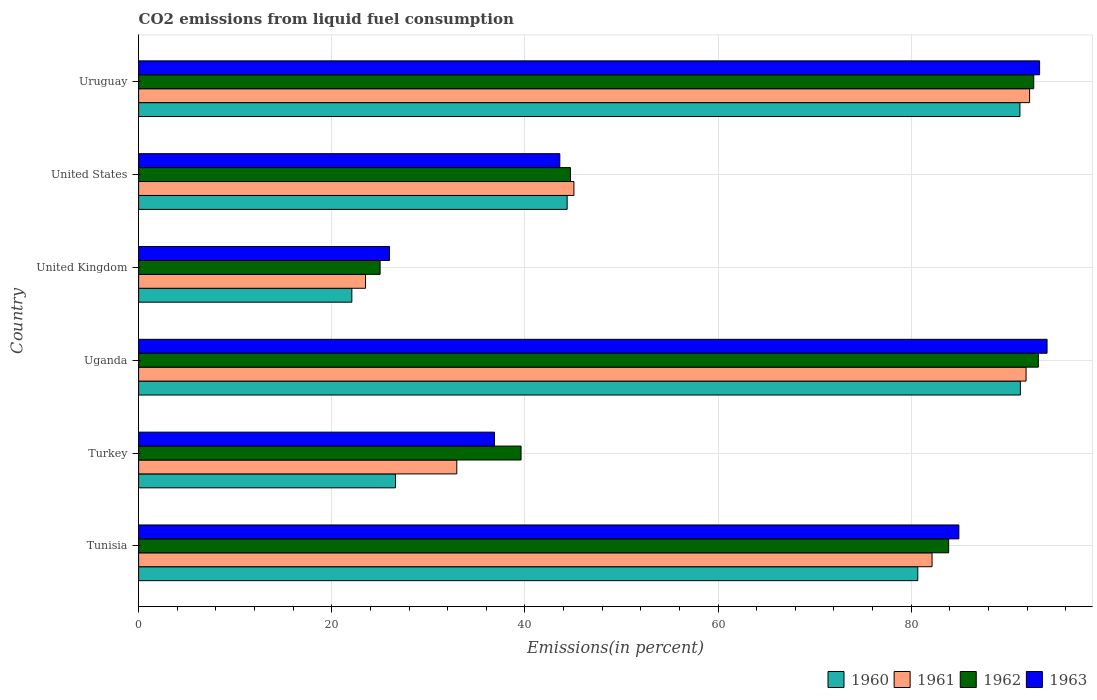How many different coloured bars are there?
Offer a terse response. 4. How many groups of bars are there?
Your response must be concise. 6. Are the number of bars on each tick of the Y-axis equal?
Offer a very short reply. Yes. How many bars are there on the 5th tick from the top?
Your answer should be compact. 4. How many bars are there on the 5th tick from the bottom?
Keep it short and to the point. 4. What is the label of the 1st group of bars from the top?
Your answer should be very brief. Uruguay. What is the total CO2 emitted in 1961 in Uruguay?
Your response must be concise. 92.26. Across all countries, what is the maximum total CO2 emitted in 1963?
Ensure brevity in your answer.  94.07. Across all countries, what is the minimum total CO2 emitted in 1960?
Provide a succinct answer. 22.08. In which country was the total CO2 emitted in 1963 maximum?
Offer a very short reply. Uganda. In which country was the total CO2 emitted in 1960 minimum?
Your response must be concise. United Kingdom. What is the total total CO2 emitted in 1962 in the graph?
Keep it short and to the point. 379.05. What is the difference between the total CO2 emitted in 1962 in Tunisia and that in Uganda?
Provide a succinct answer. -9.28. What is the difference between the total CO2 emitted in 1961 in Tunisia and the total CO2 emitted in 1963 in Uganda?
Offer a terse response. -11.91. What is the average total CO2 emitted in 1962 per country?
Ensure brevity in your answer.  63.18. What is the difference between the total CO2 emitted in 1963 and total CO2 emitted in 1962 in Uganda?
Your response must be concise. 0.91. What is the ratio of the total CO2 emitted in 1962 in Tunisia to that in Uruguay?
Provide a short and direct response. 0.9. What is the difference between the highest and the second highest total CO2 emitted in 1962?
Provide a succinct answer. 0.48. What is the difference between the highest and the lowest total CO2 emitted in 1961?
Provide a succinct answer. 68.76. In how many countries, is the total CO2 emitted in 1963 greater than the average total CO2 emitted in 1963 taken over all countries?
Your answer should be compact. 3. Is it the case that in every country, the sum of the total CO2 emitted in 1961 and total CO2 emitted in 1962 is greater than the sum of total CO2 emitted in 1960 and total CO2 emitted in 1963?
Your answer should be compact. No. What does the 2nd bar from the bottom in Tunisia represents?
Provide a succinct answer. 1961. Is it the case that in every country, the sum of the total CO2 emitted in 1963 and total CO2 emitted in 1960 is greater than the total CO2 emitted in 1961?
Your answer should be very brief. Yes. Are all the bars in the graph horizontal?
Ensure brevity in your answer.  Yes. How many countries are there in the graph?
Ensure brevity in your answer.  6. What is the difference between two consecutive major ticks on the X-axis?
Your response must be concise. 20. Are the values on the major ticks of X-axis written in scientific E-notation?
Offer a very short reply. No. Does the graph contain any zero values?
Provide a short and direct response. No. How many legend labels are there?
Keep it short and to the point. 4. What is the title of the graph?
Give a very brief answer. CO2 emissions from liquid fuel consumption. What is the label or title of the X-axis?
Provide a short and direct response. Emissions(in percent). What is the Emissions(in percent) in 1960 in Tunisia?
Your response must be concise. 80.68. What is the Emissions(in percent) of 1961 in Tunisia?
Your answer should be compact. 82.16. What is the Emissions(in percent) of 1962 in Tunisia?
Ensure brevity in your answer.  83.88. What is the Emissions(in percent) in 1963 in Tunisia?
Provide a short and direct response. 84.93. What is the Emissions(in percent) in 1960 in Turkey?
Keep it short and to the point. 26.6. What is the Emissions(in percent) of 1961 in Turkey?
Offer a very short reply. 32.95. What is the Emissions(in percent) in 1962 in Turkey?
Provide a short and direct response. 39.6. What is the Emissions(in percent) of 1963 in Turkey?
Your response must be concise. 36.85. What is the Emissions(in percent) in 1960 in Uganda?
Ensure brevity in your answer.  91.3. What is the Emissions(in percent) in 1961 in Uganda?
Provide a short and direct response. 91.89. What is the Emissions(in percent) of 1962 in Uganda?
Offer a terse response. 93.16. What is the Emissions(in percent) in 1963 in Uganda?
Keep it short and to the point. 94.07. What is the Emissions(in percent) in 1960 in United Kingdom?
Your answer should be very brief. 22.08. What is the Emissions(in percent) in 1961 in United Kingdom?
Keep it short and to the point. 23.5. What is the Emissions(in percent) of 1962 in United Kingdom?
Your answer should be compact. 25.01. What is the Emissions(in percent) of 1963 in United Kingdom?
Make the answer very short. 25.98. What is the Emissions(in percent) of 1960 in United States?
Provide a succinct answer. 44.37. What is the Emissions(in percent) of 1961 in United States?
Ensure brevity in your answer.  45.07. What is the Emissions(in percent) of 1962 in United States?
Provide a short and direct response. 44.72. What is the Emissions(in percent) in 1963 in United States?
Your answer should be compact. 43.61. What is the Emissions(in percent) in 1960 in Uruguay?
Keep it short and to the point. 91.26. What is the Emissions(in percent) in 1961 in Uruguay?
Offer a very short reply. 92.26. What is the Emissions(in percent) in 1962 in Uruguay?
Ensure brevity in your answer.  92.69. What is the Emissions(in percent) in 1963 in Uruguay?
Your response must be concise. 93.29. Across all countries, what is the maximum Emissions(in percent) of 1960?
Give a very brief answer. 91.3. Across all countries, what is the maximum Emissions(in percent) in 1961?
Keep it short and to the point. 92.26. Across all countries, what is the maximum Emissions(in percent) in 1962?
Your answer should be very brief. 93.16. Across all countries, what is the maximum Emissions(in percent) of 1963?
Offer a terse response. 94.07. Across all countries, what is the minimum Emissions(in percent) in 1960?
Your answer should be very brief. 22.08. Across all countries, what is the minimum Emissions(in percent) of 1961?
Give a very brief answer. 23.5. Across all countries, what is the minimum Emissions(in percent) of 1962?
Make the answer very short. 25.01. Across all countries, what is the minimum Emissions(in percent) in 1963?
Give a very brief answer. 25.98. What is the total Emissions(in percent) of 1960 in the graph?
Give a very brief answer. 356.29. What is the total Emissions(in percent) of 1961 in the graph?
Offer a very short reply. 367.83. What is the total Emissions(in percent) in 1962 in the graph?
Make the answer very short. 379.05. What is the total Emissions(in percent) in 1963 in the graph?
Your answer should be very brief. 378.73. What is the difference between the Emissions(in percent) in 1960 in Tunisia and that in Turkey?
Your response must be concise. 54.08. What is the difference between the Emissions(in percent) of 1961 in Tunisia and that in Turkey?
Provide a succinct answer. 49.21. What is the difference between the Emissions(in percent) of 1962 in Tunisia and that in Turkey?
Make the answer very short. 44.28. What is the difference between the Emissions(in percent) in 1963 in Tunisia and that in Turkey?
Give a very brief answer. 48.09. What is the difference between the Emissions(in percent) in 1960 in Tunisia and that in Uganda?
Provide a succinct answer. -10.62. What is the difference between the Emissions(in percent) of 1961 in Tunisia and that in Uganda?
Give a very brief answer. -9.73. What is the difference between the Emissions(in percent) of 1962 in Tunisia and that in Uganda?
Offer a terse response. -9.28. What is the difference between the Emissions(in percent) of 1963 in Tunisia and that in Uganda?
Ensure brevity in your answer.  -9.13. What is the difference between the Emissions(in percent) in 1960 in Tunisia and that in United Kingdom?
Give a very brief answer. 58.6. What is the difference between the Emissions(in percent) of 1961 in Tunisia and that in United Kingdom?
Offer a very short reply. 58.66. What is the difference between the Emissions(in percent) in 1962 in Tunisia and that in United Kingdom?
Make the answer very short. 58.87. What is the difference between the Emissions(in percent) of 1963 in Tunisia and that in United Kingdom?
Give a very brief answer. 58.96. What is the difference between the Emissions(in percent) in 1960 in Tunisia and that in United States?
Your answer should be compact. 36.31. What is the difference between the Emissions(in percent) of 1961 in Tunisia and that in United States?
Offer a very short reply. 37.08. What is the difference between the Emissions(in percent) of 1962 in Tunisia and that in United States?
Your response must be concise. 39.16. What is the difference between the Emissions(in percent) of 1963 in Tunisia and that in United States?
Offer a very short reply. 41.32. What is the difference between the Emissions(in percent) in 1960 in Tunisia and that in Uruguay?
Your answer should be compact. -10.58. What is the difference between the Emissions(in percent) of 1961 in Tunisia and that in Uruguay?
Provide a succinct answer. -10.1. What is the difference between the Emissions(in percent) of 1962 in Tunisia and that in Uruguay?
Offer a terse response. -8.81. What is the difference between the Emissions(in percent) in 1963 in Tunisia and that in Uruguay?
Make the answer very short. -8.36. What is the difference between the Emissions(in percent) in 1960 in Turkey and that in Uganda?
Offer a terse response. -64.71. What is the difference between the Emissions(in percent) of 1961 in Turkey and that in Uganda?
Provide a succinct answer. -58.95. What is the difference between the Emissions(in percent) of 1962 in Turkey and that in Uganda?
Your answer should be very brief. -53.56. What is the difference between the Emissions(in percent) in 1963 in Turkey and that in Uganda?
Your response must be concise. -57.22. What is the difference between the Emissions(in percent) in 1960 in Turkey and that in United Kingdom?
Your answer should be very brief. 4.52. What is the difference between the Emissions(in percent) of 1961 in Turkey and that in United Kingdom?
Give a very brief answer. 9.45. What is the difference between the Emissions(in percent) of 1962 in Turkey and that in United Kingdom?
Provide a succinct answer. 14.59. What is the difference between the Emissions(in percent) in 1963 in Turkey and that in United Kingdom?
Ensure brevity in your answer.  10.87. What is the difference between the Emissions(in percent) of 1960 in Turkey and that in United States?
Provide a short and direct response. -17.78. What is the difference between the Emissions(in percent) in 1961 in Turkey and that in United States?
Give a very brief answer. -12.13. What is the difference between the Emissions(in percent) of 1962 in Turkey and that in United States?
Your response must be concise. -5.12. What is the difference between the Emissions(in percent) of 1963 in Turkey and that in United States?
Your answer should be very brief. -6.76. What is the difference between the Emissions(in percent) in 1960 in Turkey and that in Uruguay?
Your answer should be compact. -64.66. What is the difference between the Emissions(in percent) in 1961 in Turkey and that in Uruguay?
Your answer should be compact. -59.31. What is the difference between the Emissions(in percent) of 1962 in Turkey and that in Uruguay?
Keep it short and to the point. -53.09. What is the difference between the Emissions(in percent) in 1963 in Turkey and that in Uruguay?
Ensure brevity in your answer.  -56.44. What is the difference between the Emissions(in percent) in 1960 in Uganda and that in United Kingdom?
Make the answer very short. 69.23. What is the difference between the Emissions(in percent) in 1961 in Uganda and that in United Kingdom?
Provide a short and direct response. 68.4. What is the difference between the Emissions(in percent) of 1962 in Uganda and that in United Kingdom?
Give a very brief answer. 68.16. What is the difference between the Emissions(in percent) in 1963 in Uganda and that in United Kingdom?
Keep it short and to the point. 68.09. What is the difference between the Emissions(in percent) in 1960 in Uganda and that in United States?
Ensure brevity in your answer.  46.93. What is the difference between the Emissions(in percent) in 1961 in Uganda and that in United States?
Provide a short and direct response. 46.82. What is the difference between the Emissions(in percent) in 1962 in Uganda and that in United States?
Give a very brief answer. 48.44. What is the difference between the Emissions(in percent) in 1963 in Uganda and that in United States?
Ensure brevity in your answer.  50.46. What is the difference between the Emissions(in percent) in 1960 in Uganda and that in Uruguay?
Give a very brief answer. 0.05. What is the difference between the Emissions(in percent) of 1961 in Uganda and that in Uruguay?
Your response must be concise. -0.37. What is the difference between the Emissions(in percent) of 1962 in Uganda and that in Uruguay?
Give a very brief answer. 0.47. What is the difference between the Emissions(in percent) of 1963 in Uganda and that in Uruguay?
Give a very brief answer. 0.77. What is the difference between the Emissions(in percent) of 1960 in United Kingdom and that in United States?
Keep it short and to the point. -22.3. What is the difference between the Emissions(in percent) of 1961 in United Kingdom and that in United States?
Provide a succinct answer. -21.58. What is the difference between the Emissions(in percent) of 1962 in United Kingdom and that in United States?
Provide a succinct answer. -19.71. What is the difference between the Emissions(in percent) of 1963 in United Kingdom and that in United States?
Offer a terse response. -17.63. What is the difference between the Emissions(in percent) of 1960 in United Kingdom and that in Uruguay?
Provide a succinct answer. -69.18. What is the difference between the Emissions(in percent) in 1961 in United Kingdom and that in Uruguay?
Ensure brevity in your answer.  -68.76. What is the difference between the Emissions(in percent) of 1962 in United Kingdom and that in Uruguay?
Make the answer very short. -67.68. What is the difference between the Emissions(in percent) of 1963 in United Kingdom and that in Uruguay?
Ensure brevity in your answer.  -67.32. What is the difference between the Emissions(in percent) of 1960 in United States and that in Uruguay?
Make the answer very short. -46.88. What is the difference between the Emissions(in percent) in 1961 in United States and that in Uruguay?
Make the answer very short. -47.19. What is the difference between the Emissions(in percent) of 1962 in United States and that in Uruguay?
Make the answer very short. -47.97. What is the difference between the Emissions(in percent) of 1963 in United States and that in Uruguay?
Ensure brevity in your answer.  -49.68. What is the difference between the Emissions(in percent) of 1960 in Tunisia and the Emissions(in percent) of 1961 in Turkey?
Give a very brief answer. 47.73. What is the difference between the Emissions(in percent) of 1960 in Tunisia and the Emissions(in percent) of 1962 in Turkey?
Your response must be concise. 41.08. What is the difference between the Emissions(in percent) of 1960 in Tunisia and the Emissions(in percent) of 1963 in Turkey?
Ensure brevity in your answer.  43.83. What is the difference between the Emissions(in percent) of 1961 in Tunisia and the Emissions(in percent) of 1962 in Turkey?
Make the answer very short. 42.56. What is the difference between the Emissions(in percent) of 1961 in Tunisia and the Emissions(in percent) of 1963 in Turkey?
Offer a very short reply. 45.31. What is the difference between the Emissions(in percent) of 1962 in Tunisia and the Emissions(in percent) of 1963 in Turkey?
Provide a succinct answer. 47.03. What is the difference between the Emissions(in percent) in 1960 in Tunisia and the Emissions(in percent) in 1961 in Uganda?
Provide a succinct answer. -11.21. What is the difference between the Emissions(in percent) in 1960 in Tunisia and the Emissions(in percent) in 1962 in Uganda?
Provide a short and direct response. -12.48. What is the difference between the Emissions(in percent) in 1960 in Tunisia and the Emissions(in percent) in 1963 in Uganda?
Provide a succinct answer. -13.39. What is the difference between the Emissions(in percent) in 1961 in Tunisia and the Emissions(in percent) in 1962 in Uganda?
Offer a very short reply. -11. What is the difference between the Emissions(in percent) of 1961 in Tunisia and the Emissions(in percent) of 1963 in Uganda?
Ensure brevity in your answer.  -11.91. What is the difference between the Emissions(in percent) in 1962 in Tunisia and the Emissions(in percent) in 1963 in Uganda?
Offer a terse response. -10.19. What is the difference between the Emissions(in percent) in 1960 in Tunisia and the Emissions(in percent) in 1961 in United Kingdom?
Your response must be concise. 57.18. What is the difference between the Emissions(in percent) of 1960 in Tunisia and the Emissions(in percent) of 1962 in United Kingdom?
Make the answer very short. 55.67. What is the difference between the Emissions(in percent) in 1960 in Tunisia and the Emissions(in percent) in 1963 in United Kingdom?
Your answer should be compact. 54.7. What is the difference between the Emissions(in percent) in 1961 in Tunisia and the Emissions(in percent) in 1962 in United Kingdom?
Offer a terse response. 57.15. What is the difference between the Emissions(in percent) in 1961 in Tunisia and the Emissions(in percent) in 1963 in United Kingdom?
Ensure brevity in your answer.  56.18. What is the difference between the Emissions(in percent) in 1962 in Tunisia and the Emissions(in percent) in 1963 in United Kingdom?
Give a very brief answer. 57.9. What is the difference between the Emissions(in percent) of 1960 in Tunisia and the Emissions(in percent) of 1961 in United States?
Your response must be concise. 35.6. What is the difference between the Emissions(in percent) in 1960 in Tunisia and the Emissions(in percent) in 1962 in United States?
Your answer should be compact. 35.96. What is the difference between the Emissions(in percent) of 1960 in Tunisia and the Emissions(in percent) of 1963 in United States?
Ensure brevity in your answer.  37.07. What is the difference between the Emissions(in percent) in 1961 in Tunisia and the Emissions(in percent) in 1962 in United States?
Give a very brief answer. 37.44. What is the difference between the Emissions(in percent) of 1961 in Tunisia and the Emissions(in percent) of 1963 in United States?
Keep it short and to the point. 38.55. What is the difference between the Emissions(in percent) in 1962 in Tunisia and the Emissions(in percent) in 1963 in United States?
Make the answer very short. 40.27. What is the difference between the Emissions(in percent) in 1960 in Tunisia and the Emissions(in percent) in 1961 in Uruguay?
Offer a very short reply. -11.58. What is the difference between the Emissions(in percent) in 1960 in Tunisia and the Emissions(in percent) in 1962 in Uruguay?
Ensure brevity in your answer.  -12.01. What is the difference between the Emissions(in percent) in 1960 in Tunisia and the Emissions(in percent) in 1963 in Uruguay?
Make the answer very short. -12.61. What is the difference between the Emissions(in percent) in 1961 in Tunisia and the Emissions(in percent) in 1962 in Uruguay?
Give a very brief answer. -10.53. What is the difference between the Emissions(in percent) in 1961 in Tunisia and the Emissions(in percent) in 1963 in Uruguay?
Make the answer very short. -11.14. What is the difference between the Emissions(in percent) of 1962 in Tunisia and the Emissions(in percent) of 1963 in Uruguay?
Your answer should be compact. -9.42. What is the difference between the Emissions(in percent) in 1960 in Turkey and the Emissions(in percent) in 1961 in Uganda?
Provide a short and direct response. -65.3. What is the difference between the Emissions(in percent) in 1960 in Turkey and the Emissions(in percent) in 1962 in Uganda?
Provide a short and direct response. -66.57. What is the difference between the Emissions(in percent) of 1960 in Turkey and the Emissions(in percent) of 1963 in Uganda?
Provide a succinct answer. -67.47. What is the difference between the Emissions(in percent) in 1961 in Turkey and the Emissions(in percent) in 1962 in Uganda?
Your answer should be compact. -60.22. What is the difference between the Emissions(in percent) of 1961 in Turkey and the Emissions(in percent) of 1963 in Uganda?
Make the answer very short. -61.12. What is the difference between the Emissions(in percent) in 1962 in Turkey and the Emissions(in percent) in 1963 in Uganda?
Keep it short and to the point. -54.47. What is the difference between the Emissions(in percent) of 1960 in Turkey and the Emissions(in percent) of 1961 in United Kingdom?
Your answer should be very brief. 3.1. What is the difference between the Emissions(in percent) of 1960 in Turkey and the Emissions(in percent) of 1962 in United Kingdom?
Keep it short and to the point. 1.59. What is the difference between the Emissions(in percent) in 1960 in Turkey and the Emissions(in percent) in 1963 in United Kingdom?
Provide a short and direct response. 0.62. What is the difference between the Emissions(in percent) of 1961 in Turkey and the Emissions(in percent) of 1962 in United Kingdom?
Give a very brief answer. 7.94. What is the difference between the Emissions(in percent) of 1961 in Turkey and the Emissions(in percent) of 1963 in United Kingdom?
Your answer should be compact. 6.97. What is the difference between the Emissions(in percent) of 1962 in Turkey and the Emissions(in percent) of 1963 in United Kingdom?
Keep it short and to the point. 13.62. What is the difference between the Emissions(in percent) of 1960 in Turkey and the Emissions(in percent) of 1961 in United States?
Offer a terse response. -18.48. What is the difference between the Emissions(in percent) in 1960 in Turkey and the Emissions(in percent) in 1962 in United States?
Offer a very short reply. -18.12. What is the difference between the Emissions(in percent) in 1960 in Turkey and the Emissions(in percent) in 1963 in United States?
Give a very brief answer. -17.02. What is the difference between the Emissions(in percent) of 1961 in Turkey and the Emissions(in percent) of 1962 in United States?
Provide a succinct answer. -11.77. What is the difference between the Emissions(in percent) in 1961 in Turkey and the Emissions(in percent) in 1963 in United States?
Give a very brief answer. -10.67. What is the difference between the Emissions(in percent) in 1962 in Turkey and the Emissions(in percent) in 1963 in United States?
Ensure brevity in your answer.  -4.01. What is the difference between the Emissions(in percent) in 1960 in Turkey and the Emissions(in percent) in 1961 in Uruguay?
Provide a short and direct response. -65.66. What is the difference between the Emissions(in percent) in 1960 in Turkey and the Emissions(in percent) in 1962 in Uruguay?
Provide a short and direct response. -66.09. What is the difference between the Emissions(in percent) of 1960 in Turkey and the Emissions(in percent) of 1963 in Uruguay?
Keep it short and to the point. -66.7. What is the difference between the Emissions(in percent) in 1961 in Turkey and the Emissions(in percent) in 1962 in Uruguay?
Keep it short and to the point. -59.74. What is the difference between the Emissions(in percent) in 1961 in Turkey and the Emissions(in percent) in 1963 in Uruguay?
Provide a short and direct response. -60.35. What is the difference between the Emissions(in percent) of 1962 in Turkey and the Emissions(in percent) of 1963 in Uruguay?
Provide a short and direct response. -53.69. What is the difference between the Emissions(in percent) in 1960 in Uganda and the Emissions(in percent) in 1961 in United Kingdom?
Keep it short and to the point. 67.81. What is the difference between the Emissions(in percent) in 1960 in Uganda and the Emissions(in percent) in 1962 in United Kingdom?
Keep it short and to the point. 66.3. What is the difference between the Emissions(in percent) of 1960 in Uganda and the Emissions(in percent) of 1963 in United Kingdom?
Provide a succinct answer. 65.33. What is the difference between the Emissions(in percent) in 1961 in Uganda and the Emissions(in percent) in 1962 in United Kingdom?
Your answer should be very brief. 66.89. What is the difference between the Emissions(in percent) of 1961 in Uganda and the Emissions(in percent) of 1963 in United Kingdom?
Keep it short and to the point. 65.91. What is the difference between the Emissions(in percent) in 1962 in Uganda and the Emissions(in percent) in 1963 in United Kingdom?
Keep it short and to the point. 67.18. What is the difference between the Emissions(in percent) in 1960 in Uganda and the Emissions(in percent) in 1961 in United States?
Keep it short and to the point. 46.23. What is the difference between the Emissions(in percent) of 1960 in Uganda and the Emissions(in percent) of 1962 in United States?
Make the answer very short. 46.59. What is the difference between the Emissions(in percent) of 1960 in Uganda and the Emissions(in percent) of 1963 in United States?
Provide a short and direct response. 47.69. What is the difference between the Emissions(in percent) in 1961 in Uganda and the Emissions(in percent) in 1962 in United States?
Your answer should be compact. 47.17. What is the difference between the Emissions(in percent) in 1961 in Uganda and the Emissions(in percent) in 1963 in United States?
Offer a terse response. 48.28. What is the difference between the Emissions(in percent) of 1962 in Uganda and the Emissions(in percent) of 1963 in United States?
Provide a short and direct response. 49.55. What is the difference between the Emissions(in percent) of 1960 in Uganda and the Emissions(in percent) of 1961 in Uruguay?
Provide a short and direct response. -0.96. What is the difference between the Emissions(in percent) of 1960 in Uganda and the Emissions(in percent) of 1962 in Uruguay?
Provide a succinct answer. -1.38. What is the difference between the Emissions(in percent) of 1960 in Uganda and the Emissions(in percent) of 1963 in Uruguay?
Offer a very short reply. -1.99. What is the difference between the Emissions(in percent) in 1961 in Uganda and the Emissions(in percent) in 1962 in Uruguay?
Provide a succinct answer. -0.8. What is the difference between the Emissions(in percent) of 1961 in Uganda and the Emissions(in percent) of 1963 in Uruguay?
Provide a short and direct response. -1.4. What is the difference between the Emissions(in percent) in 1962 in Uganda and the Emissions(in percent) in 1963 in Uruguay?
Provide a short and direct response. -0.13. What is the difference between the Emissions(in percent) of 1960 in United Kingdom and the Emissions(in percent) of 1961 in United States?
Give a very brief answer. -23. What is the difference between the Emissions(in percent) in 1960 in United Kingdom and the Emissions(in percent) in 1962 in United States?
Make the answer very short. -22.64. What is the difference between the Emissions(in percent) of 1960 in United Kingdom and the Emissions(in percent) of 1963 in United States?
Ensure brevity in your answer.  -21.54. What is the difference between the Emissions(in percent) of 1961 in United Kingdom and the Emissions(in percent) of 1962 in United States?
Ensure brevity in your answer.  -21.22. What is the difference between the Emissions(in percent) in 1961 in United Kingdom and the Emissions(in percent) in 1963 in United States?
Offer a terse response. -20.12. What is the difference between the Emissions(in percent) of 1962 in United Kingdom and the Emissions(in percent) of 1963 in United States?
Offer a terse response. -18.61. What is the difference between the Emissions(in percent) in 1960 in United Kingdom and the Emissions(in percent) in 1961 in Uruguay?
Your response must be concise. -70.18. What is the difference between the Emissions(in percent) of 1960 in United Kingdom and the Emissions(in percent) of 1962 in Uruguay?
Offer a very short reply. -70.61. What is the difference between the Emissions(in percent) of 1960 in United Kingdom and the Emissions(in percent) of 1963 in Uruguay?
Your answer should be very brief. -71.22. What is the difference between the Emissions(in percent) in 1961 in United Kingdom and the Emissions(in percent) in 1962 in Uruguay?
Provide a short and direct response. -69.19. What is the difference between the Emissions(in percent) in 1961 in United Kingdom and the Emissions(in percent) in 1963 in Uruguay?
Keep it short and to the point. -69.8. What is the difference between the Emissions(in percent) of 1962 in United Kingdom and the Emissions(in percent) of 1963 in Uruguay?
Give a very brief answer. -68.29. What is the difference between the Emissions(in percent) of 1960 in United States and the Emissions(in percent) of 1961 in Uruguay?
Provide a succinct answer. -47.89. What is the difference between the Emissions(in percent) of 1960 in United States and the Emissions(in percent) of 1962 in Uruguay?
Offer a terse response. -48.31. What is the difference between the Emissions(in percent) of 1960 in United States and the Emissions(in percent) of 1963 in Uruguay?
Provide a succinct answer. -48.92. What is the difference between the Emissions(in percent) in 1961 in United States and the Emissions(in percent) in 1962 in Uruguay?
Offer a terse response. -47.61. What is the difference between the Emissions(in percent) in 1961 in United States and the Emissions(in percent) in 1963 in Uruguay?
Give a very brief answer. -48.22. What is the difference between the Emissions(in percent) in 1962 in United States and the Emissions(in percent) in 1963 in Uruguay?
Provide a short and direct response. -48.58. What is the average Emissions(in percent) in 1960 per country?
Offer a terse response. 59.38. What is the average Emissions(in percent) in 1961 per country?
Provide a succinct answer. 61.3. What is the average Emissions(in percent) in 1962 per country?
Your answer should be very brief. 63.18. What is the average Emissions(in percent) of 1963 per country?
Keep it short and to the point. 63.12. What is the difference between the Emissions(in percent) of 1960 and Emissions(in percent) of 1961 in Tunisia?
Your response must be concise. -1.48. What is the difference between the Emissions(in percent) of 1960 and Emissions(in percent) of 1962 in Tunisia?
Offer a very short reply. -3.2. What is the difference between the Emissions(in percent) in 1960 and Emissions(in percent) in 1963 in Tunisia?
Ensure brevity in your answer.  -4.25. What is the difference between the Emissions(in percent) in 1961 and Emissions(in percent) in 1962 in Tunisia?
Your answer should be compact. -1.72. What is the difference between the Emissions(in percent) of 1961 and Emissions(in percent) of 1963 in Tunisia?
Make the answer very short. -2.78. What is the difference between the Emissions(in percent) of 1962 and Emissions(in percent) of 1963 in Tunisia?
Provide a short and direct response. -1.06. What is the difference between the Emissions(in percent) of 1960 and Emissions(in percent) of 1961 in Turkey?
Your answer should be compact. -6.35. What is the difference between the Emissions(in percent) of 1960 and Emissions(in percent) of 1962 in Turkey?
Offer a very short reply. -13. What is the difference between the Emissions(in percent) in 1960 and Emissions(in percent) in 1963 in Turkey?
Your answer should be very brief. -10.25. What is the difference between the Emissions(in percent) in 1961 and Emissions(in percent) in 1962 in Turkey?
Ensure brevity in your answer.  -6.65. What is the difference between the Emissions(in percent) in 1961 and Emissions(in percent) in 1963 in Turkey?
Your answer should be very brief. -3.9. What is the difference between the Emissions(in percent) in 1962 and Emissions(in percent) in 1963 in Turkey?
Make the answer very short. 2.75. What is the difference between the Emissions(in percent) of 1960 and Emissions(in percent) of 1961 in Uganda?
Provide a succinct answer. -0.59. What is the difference between the Emissions(in percent) of 1960 and Emissions(in percent) of 1962 in Uganda?
Offer a very short reply. -1.86. What is the difference between the Emissions(in percent) of 1960 and Emissions(in percent) of 1963 in Uganda?
Your answer should be very brief. -2.76. What is the difference between the Emissions(in percent) in 1961 and Emissions(in percent) in 1962 in Uganda?
Offer a very short reply. -1.27. What is the difference between the Emissions(in percent) in 1961 and Emissions(in percent) in 1963 in Uganda?
Offer a terse response. -2.18. What is the difference between the Emissions(in percent) in 1962 and Emissions(in percent) in 1963 in Uganda?
Offer a terse response. -0.91. What is the difference between the Emissions(in percent) in 1960 and Emissions(in percent) in 1961 in United Kingdom?
Provide a succinct answer. -1.42. What is the difference between the Emissions(in percent) of 1960 and Emissions(in percent) of 1962 in United Kingdom?
Offer a very short reply. -2.93. What is the difference between the Emissions(in percent) in 1960 and Emissions(in percent) in 1963 in United Kingdom?
Offer a terse response. -3.9. What is the difference between the Emissions(in percent) of 1961 and Emissions(in percent) of 1962 in United Kingdom?
Keep it short and to the point. -1.51. What is the difference between the Emissions(in percent) of 1961 and Emissions(in percent) of 1963 in United Kingdom?
Offer a terse response. -2.48. What is the difference between the Emissions(in percent) of 1962 and Emissions(in percent) of 1963 in United Kingdom?
Your answer should be compact. -0.97. What is the difference between the Emissions(in percent) of 1960 and Emissions(in percent) of 1961 in United States?
Make the answer very short. -0.7. What is the difference between the Emissions(in percent) in 1960 and Emissions(in percent) in 1962 in United States?
Your response must be concise. -0.35. What is the difference between the Emissions(in percent) of 1960 and Emissions(in percent) of 1963 in United States?
Your response must be concise. 0.76. What is the difference between the Emissions(in percent) in 1961 and Emissions(in percent) in 1962 in United States?
Offer a terse response. 0.36. What is the difference between the Emissions(in percent) in 1961 and Emissions(in percent) in 1963 in United States?
Keep it short and to the point. 1.46. What is the difference between the Emissions(in percent) of 1962 and Emissions(in percent) of 1963 in United States?
Offer a terse response. 1.11. What is the difference between the Emissions(in percent) in 1960 and Emissions(in percent) in 1961 in Uruguay?
Keep it short and to the point. -1. What is the difference between the Emissions(in percent) in 1960 and Emissions(in percent) in 1962 in Uruguay?
Ensure brevity in your answer.  -1.43. What is the difference between the Emissions(in percent) of 1960 and Emissions(in percent) of 1963 in Uruguay?
Make the answer very short. -2.04. What is the difference between the Emissions(in percent) in 1961 and Emissions(in percent) in 1962 in Uruguay?
Your answer should be very brief. -0.43. What is the difference between the Emissions(in percent) of 1961 and Emissions(in percent) of 1963 in Uruguay?
Make the answer very short. -1.03. What is the difference between the Emissions(in percent) of 1962 and Emissions(in percent) of 1963 in Uruguay?
Ensure brevity in your answer.  -0.61. What is the ratio of the Emissions(in percent) of 1960 in Tunisia to that in Turkey?
Provide a short and direct response. 3.03. What is the ratio of the Emissions(in percent) in 1961 in Tunisia to that in Turkey?
Provide a short and direct response. 2.49. What is the ratio of the Emissions(in percent) in 1962 in Tunisia to that in Turkey?
Your answer should be compact. 2.12. What is the ratio of the Emissions(in percent) of 1963 in Tunisia to that in Turkey?
Give a very brief answer. 2.3. What is the ratio of the Emissions(in percent) of 1960 in Tunisia to that in Uganda?
Give a very brief answer. 0.88. What is the ratio of the Emissions(in percent) of 1961 in Tunisia to that in Uganda?
Provide a succinct answer. 0.89. What is the ratio of the Emissions(in percent) of 1962 in Tunisia to that in Uganda?
Make the answer very short. 0.9. What is the ratio of the Emissions(in percent) of 1963 in Tunisia to that in Uganda?
Offer a very short reply. 0.9. What is the ratio of the Emissions(in percent) of 1960 in Tunisia to that in United Kingdom?
Give a very brief answer. 3.65. What is the ratio of the Emissions(in percent) of 1961 in Tunisia to that in United Kingdom?
Your response must be concise. 3.5. What is the ratio of the Emissions(in percent) in 1962 in Tunisia to that in United Kingdom?
Your answer should be compact. 3.35. What is the ratio of the Emissions(in percent) in 1963 in Tunisia to that in United Kingdom?
Offer a terse response. 3.27. What is the ratio of the Emissions(in percent) in 1960 in Tunisia to that in United States?
Your answer should be compact. 1.82. What is the ratio of the Emissions(in percent) of 1961 in Tunisia to that in United States?
Provide a short and direct response. 1.82. What is the ratio of the Emissions(in percent) in 1962 in Tunisia to that in United States?
Your response must be concise. 1.88. What is the ratio of the Emissions(in percent) of 1963 in Tunisia to that in United States?
Keep it short and to the point. 1.95. What is the ratio of the Emissions(in percent) in 1960 in Tunisia to that in Uruguay?
Your answer should be very brief. 0.88. What is the ratio of the Emissions(in percent) in 1961 in Tunisia to that in Uruguay?
Make the answer very short. 0.89. What is the ratio of the Emissions(in percent) of 1962 in Tunisia to that in Uruguay?
Provide a short and direct response. 0.91. What is the ratio of the Emissions(in percent) in 1963 in Tunisia to that in Uruguay?
Your answer should be compact. 0.91. What is the ratio of the Emissions(in percent) in 1960 in Turkey to that in Uganda?
Offer a terse response. 0.29. What is the ratio of the Emissions(in percent) of 1961 in Turkey to that in Uganda?
Keep it short and to the point. 0.36. What is the ratio of the Emissions(in percent) in 1962 in Turkey to that in Uganda?
Offer a very short reply. 0.43. What is the ratio of the Emissions(in percent) in 1963 in Turkey to that in Uganda?
Your answer should be compact. 0.39. What is the ratio of the Emissions(in percent) in 1960 in Turkey to that in United Kingdom?
Offer a very short reply. 1.2. What is the ratio of the Emissions(in percent) in 1961 in Turkey to that in United Kingdom?
Give a very brief answer. 1.4. What is the ratio of the Emissions(in percent) of 1962 in Turkey to that in United Kingdom?
Keep it short and to the point. 1.58. What is the ratio of the Emissions(in percent) in 1963 in Turkey to that in United Kingdom?
Provide a succinct answer. 1.42. What is the ratio of the Emissions(in percent) in 1960 in Turkey to that in United States?
Make the answer very short. 0.6. What is the ratio of the Emissions(in percent) of 1961 in Turkey to that in United States?
Keep it short and to the point. 0.73. What is the ratio of the Emissions(in percent) of 1962 in Turkey to that in United States?
Offer a terse response. 0.89. What is the ratio of the Emissions(in percent) of 1963 in Turkey to that in United States?
Offer a terse response. 0.84. What is the ratio of the Emissions(in percent) in 1960 in Turkey to that in Uruguay?
Provide a short and direct response. 0.29. What is the ratio of the Emissions(in percent) of 1961 in Turkey to that in Uruguay?
Provide a succinct answer. 0.36. What is the ratio of the Emissions(in percent) in 1962 in Turkey to that in Uruguay?
Your answer should be compact. 0.43. What is the ratio of the Emissions(in percent) of 1963 in Turkey to that in Uruguay?
Provide a succinct answer. 0.4. What is the ratio of the Emissions(in percent) in 1960 in Uganda to that in United Kingdom?
Provide a succinct answer. 4.14. What is the ratio of the Emissions(in percent) in 1961 in Uganda to that in United Kingdom?
Provide a succinct answer. 3.91. What is the ratio of the Emissions(in percent) in 1962 in Uganda to that in United Kingdom?
Keep it short and to the point. 3.73. What is the ratio of the Emissions(in percent) of 1963 in Uganda to that in United Kingdom?
Your answer should be compact. 3.62. What is the ratio of the Emissions(in percent) of 1960 in Uganda to that in United States?
Your answer should be very brief. 2.06. What is the ratio of the Emissions(in percent) of 1961 in Uganda to that in United States?
Ensure brevity in your answer.  2.04. What is the ratio of the Emissions(in percent) in 1962 in Uganda to that in United States?
Offer a very short reply. 2.08. What is the ratio of the Emissions(in percent) of 1963 in Uganda to that in United States?
Your response must be concise. 2.16. What is the ratio of the Emissions(in percent) of 1960 in Uganda to that in Uruguay?
Your response must be concise. 1. What is the ratio of the Emissions(in percent) in 1962 in Uganda to that in Uruguay?
Provide a short and direct response. 1.01. What is the ratio of the Emissions(in percent) of 1963 in Uganda to that in Uruguay?
Ensure brevity in your answer.  1.01. What is the ratio of the Emissions(in percent) of 1960 in United Kingdom to that in United States?
Offer a very short reply. 0.5. What is the ratio of the Emissions(in percent) of 1961 in United Kingdom to that in United States?
Ensure brevity in your answer.  0.52. What is the ratio of the Emissions(in percent) in 1962 in United Kingdom to that in United States?
Give a very brief answer. 0.56. What is the ratio of the Emissions(in percent) of 1963 in United Kingdom to that in United States?
Your answer should be very brief. 0.6. What is the ratio of the Emissions(in percent) of 1960 in United Kingdom to that in Uruguay?
Keep it short and to the point. 0.24. What is the ratio of the Emissions(in percent) of 1961 in United Kingdom to that in Uruguay?
Offer a very short reply. 0.25. What is the ratio of the Emissions(in percent) of 1962 in United Kingdom to that in Uruguay?
Offer a terse response. 0.27. What is the ratio of the Emissions(in percent) of 1963 in United Kingdom to that in Uruguay?
Keep it short and to the point. 0.28. What is the ratio of the Emissions(in percent) of 1960 in United States to that in Uruguay?
Offer a terse response. 0.49. What is the ratio of the Emissions(in percent) of 1961 in United States to that in Uruguay?
Your answer should be very brief. 0.49. What is the ratio of the Emissions(in percent) in 1962 in United States to that in Uruguay?
Your response must be concise. 0.48. What is the ratio of the Emissions(in percent) of 1963 in United States to that in Uruguay?
Your response must be concise. 0.47. What is the difference between the highest and the second highest Emissions(in percent) in 1960?
Your answer should be very brief. 0.05. What is the difference between the highest and the second highest Emissions(in percent) in 1961?
Your response must be concise. 0.37. What is the difference between the highest and the second highest Emissions(in percent) in 1962?
Provide a succinct answer. 0.47. What is the difference between the highest and the second highest Emissions(in percent) of 1963?
Provide a short and direct response. 0.77. What is the difference between the highest and the lowest Emissions(in percent) of 1960?
Make the answer very short. 69.23. What is the difference between the highest and the lowest Emissions(in percent) in 1961?
Offer a very short reply. 68.76. What is the difference between the highest and the lowest Emissions(in percent) of 1962?
Make the answer very short. 68.16. What is the difference between the highest and the lowest Emissions(in percent) of 1963?
Keep it short and to the point. 68.09. 